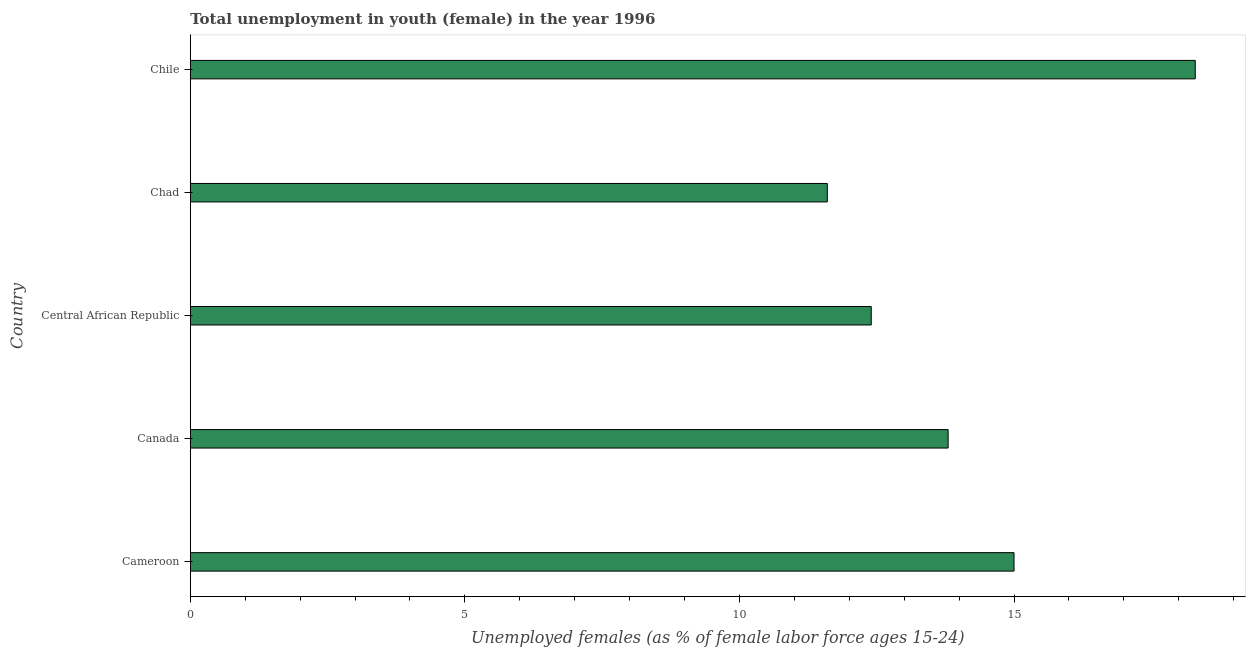Does the graph contain any zero values?
Provide a short and direct response. No. What is the title of the graph?
Provide a short and direct response. Total unemployment in youth (female) in the year 1996. What is the label or title of the X-axis?
Your response must be concise. Unemployed females (as % of female labor force ages 15-24). What is the label or title of the Y-axis?
Your answer should be very brief. Country. What is the unemployed female youth population in Canada?
Offer a terse response. 13.8. Across all countries, what is the maximum unemployed female youth population?
Offer a terse response. 18.3. Across all countries, what is the minimum unemployed female youth population?
Your answer should be very brief. 11.6. In which country was the unemployed female youth population maximum?
Ensure brevity in your answer.  Chile. In which country was the unemployed female youth population minimum?
Offer a terse response. Chad. What is the sum of the unemployed female youth population?
Offer a terse response. 71.1. What is the average unemployed female youth population per country?
Provide a succinct answer. 14.22. What is the median unemployed female youth population?
Provide a short and direct response. 13.8. In how many countries, is the unemployed female youth population greater than 13 %?
Offer a terse response. 3. What is the ratio of the unemployed female youth population in Cameroon to that in Chile?
Provide a succinct answer. 0.82. Is the unemployed female youth population in Cameroon less than that in Canada?
Keep it short and to the point. No. Is the difference between the unemployed female youth population in Cameroon and Chile greater than the difference between any two countries?
Provide a succinct answer. No. What is the difference between the highest and the second highest unemployed female youth population?
Ensure brevity in your answer.  3.3. Is the sum of the unemployed female youth population in Central African Republic and Chad greater than the maximum unemployed female youth population across all countries?
Offer a terse response. Yes. What is the difference between the highest and the lowest unemployed female youth population?
Your answer should be very brief. 6.7. Are the values on the major ticks of X-axis written in scientific E-notation?
Give a very brief answer. No. What is the Unemployed females (as % of female labor force ages 15-24) of Cameroon?
Make the answer very short. 15. What is the Unemployed females (as % of female labor force ages 15-24) in Canada?
Offer a terse response. 13.8. What is the Unemployed females (as % of female labor force ages 15-24) in Central African Republic?
Your answer should be very brief. 12.4. What is the Unemployed females (as % of female labor force ages 15-24) of Chad?
Make the answer very short. 11.6. What is the Unemployed females (as % of female labor force ages 15-24) of Chile?
Give a very brief answer. 18.3. What is the difference between the Unemployed females (as % of female labor force ages 15-24) in Cameroon and Chad?
Offer a terse response. 3.4. What is the difference between the Unemployed females (as % of female labor force ages 15-24) in Cameroon and Chile?
Ensure brevity in your answer.  -3.3. What is the difference between the Unemployed females (as % of female labor force ages 15-24) in Chad and Chile?
Your answer should be very brief. -6.7. What is the ratio of the Unemployed females (as % of female labor force ages 15-24) in Cameroon to that in Canada?
Your answer should be very brief. 1.09. What is the ratio of the Unemployed females (as % of female labor force ages 15-24) in Cameroon to that in Central African Republic?
Keep it short and to the point. 1.21. What is the ratio of the Unemployed females (as % of female labor force ages 15-24) in Cameroon to that in Chad?
Your answer should be compact. 1.29. What is the ratio of the Unemployed females (as % of female labor force ages 15-24) in Cameroon to that in Chile?
Offer a terse response. 0.82. What is the ratio of the Unemployed females (as % of female labor force ages 15-24) in Canada to that in Central African Republic?
Offer a very short reply. 1.11. What is the ratio of the Unemployed females (as % of female labor force ages 15-24) in Canada to that in Chad?
Make the answer very short. 1.19. What is the ratio of the Unemployed females (as % of female labor force ages 15-24) in Canada to that in Chile?
Ensure brevity in your answer.  0.75. What is the ratio of the Unemployed females (as % of female labor force ages 15-24) in Central African Republic to that in Chad?
Offer a terse response. 1.07. What is the ratio of the Unemployed females (as % of female labor force ages 15-24) in Central African Republic to that in Chile?
Offer a terse response. 0.68. What is the ratio of the Unemployed females (as % of female labor force ages 15-24) in Chad to that in Chile?
Provide a short and direct response. 0.63. 